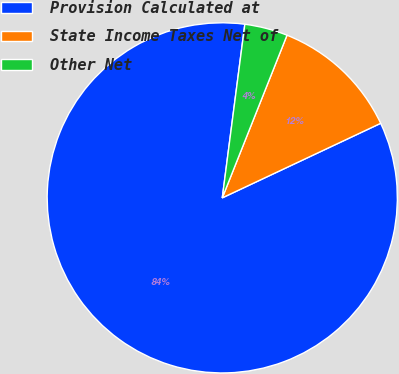<chart> <loc_0><loc_0><loc_500><loc_500><pie_chart><fcel>Provision Calculated at<fcel>State Income Taxes Net of<fcel>Other Net<nl><fcel>84.06%<fcel>11.97%<fcel>3.97%<nl></chart> 